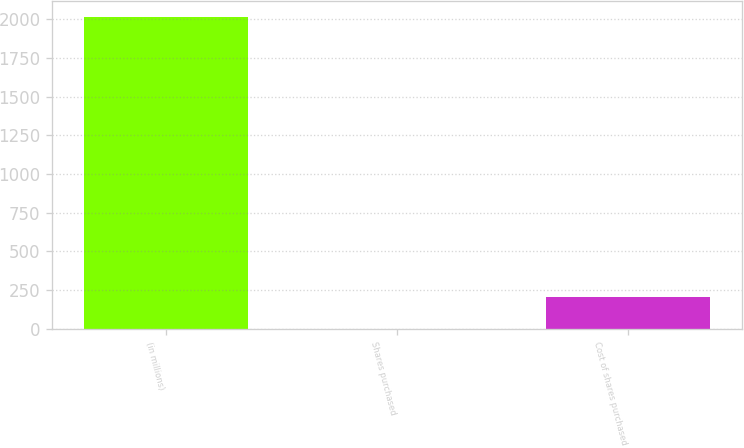Convert chart to OTSL. <chart><loc_0><loc_0><loc_500><loc_500><bar_chart><fcel>(in millions)<fcel>Shares purchased<fcel>Cost of shares purchased<nl><fcel>2017<fcel>1.1<fcel>202.69<nl></chart> 